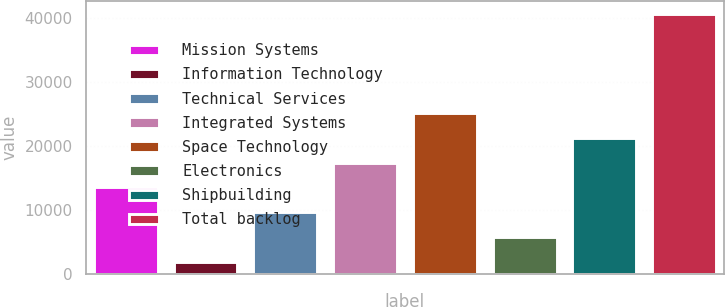<chart> <loc_0><loc_0><loc_500><loc_500><bar_chart><fcel>Mission Systems<fcel>Information Technology<fcel>Technical Services<fcel>Integrated Systems<fcel>Space Technology<fcel>Electronics<fcel>Shipbuilding<fcel>Total backlog<nl><fcel>13526.7<fcel>1899<fcel>9650.8<fcel>17402.6<fcel>25154.4<fcel>5774.9<fcel>21278.5<fcel>40658<nl></chart> 